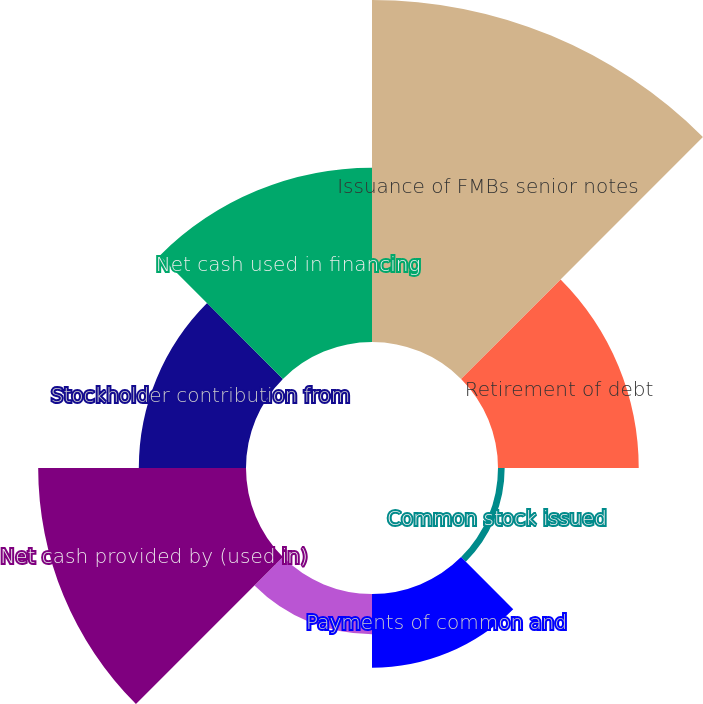Convert chart to OTSL. <chart><loc_0><loc_0><loc_500><loc_500><pie_chart><fcel>Issuance of FMBs senior notes<fcel>Retirement of debt<fcel>Common stock issued<fcel>Payments of common and<fcel>Other financing activities<fcel>Net cash provided by (used in)<fcel>Stockholder contribution from<fcel>Net cash used in financing<nl><fcel>31.3%<fcel>12.88%<fcel>0.61%<fcel>6.75%<fcel>3.68%<fcel>19.02%<fcel>9.81%<fcel>15.95%<nl></chart> 